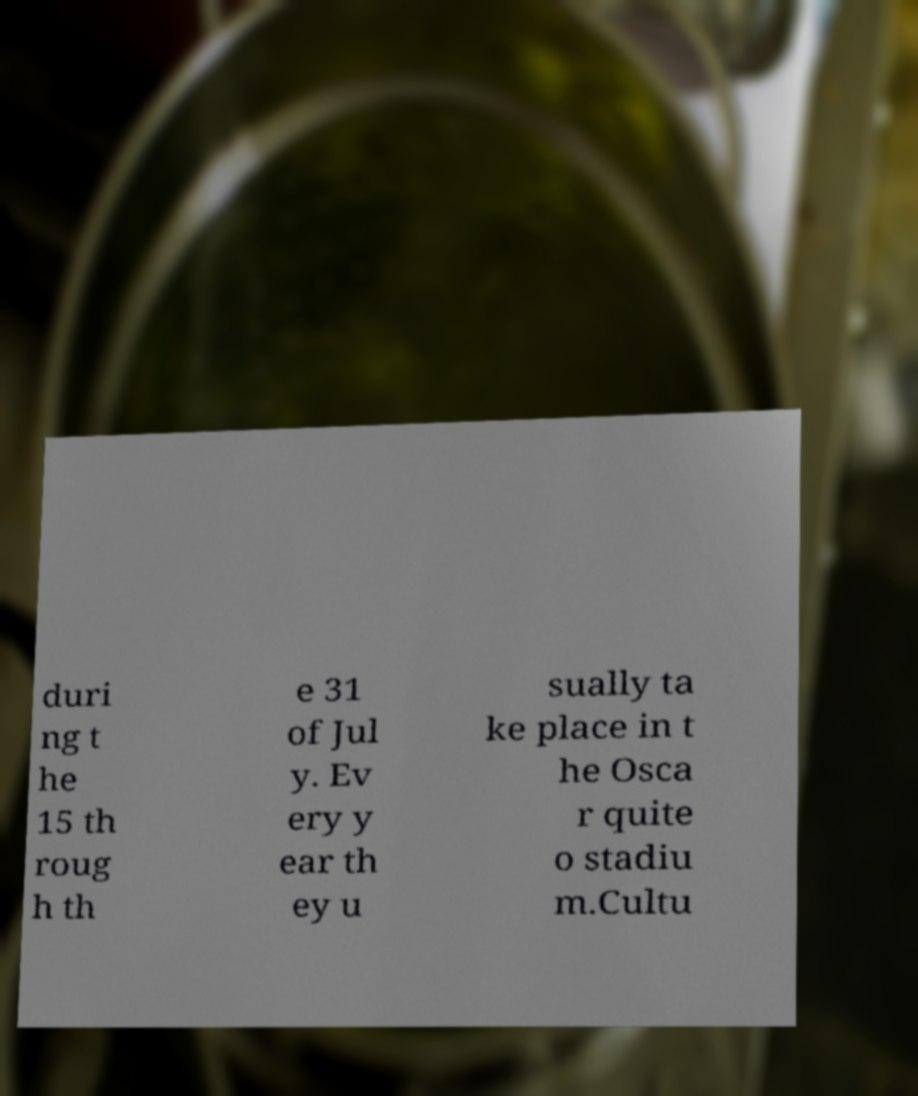I need the written content from this picture converted into text. Can you do that? duri ng t he 15 th roug h th e 31 of Jul y. Ev ery y ear th ey u sually ta ke place in t he Osca r quite o stadiu m.Cultu 